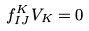<formula> <loc_0><loc_0><loc_500><loc_500>f ^ { K } _ { I J } V _ { K } = 0</formula> 